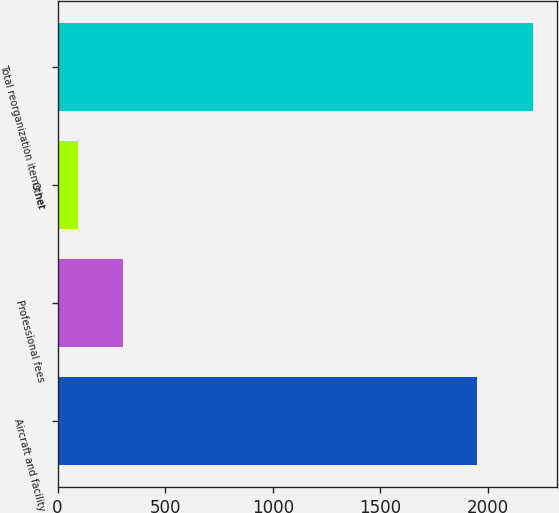<chart> <loc_0><loc_0><loc_500><loc_500><bar_chart><fcel>Aircraft and facility<fcel>Professional fees<fcel>Other<fcel>Total reorganization items net<nl><fcel>1950<fcel>306.3<fcel>95<fcel>2208<nl></chart> 